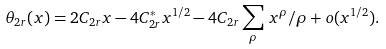<formula> <loc_0><loc_0><loc_500><loc_500>\theta _ { 2 r } ( x ) = 2 C _ { 2 r } x - 4 C ^ { * } _ { 2 r } x ^ { 1 / 2 } - 4 C _ { 2 r } \sum _ { \rho } \, x ^ { \rho } / \rho + o ( x ^ { 1 / 2 } ) .</formula> 